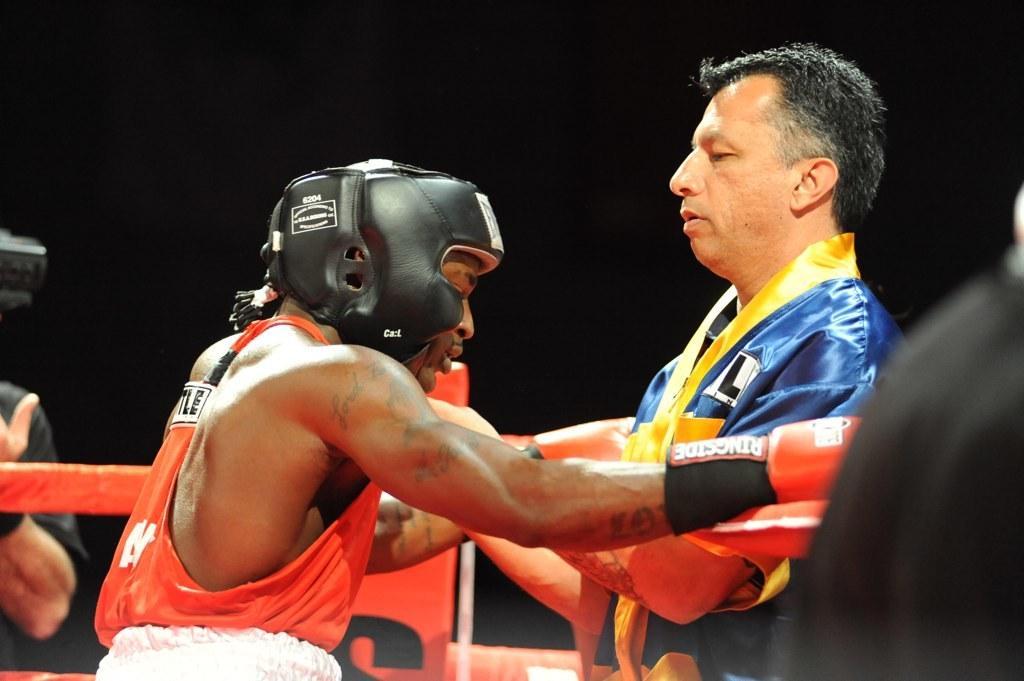Please provide a concise description of this image. In the middle of the image two persons are standing. Behind them there is fencing. Behind the fencing we can see a hand. 